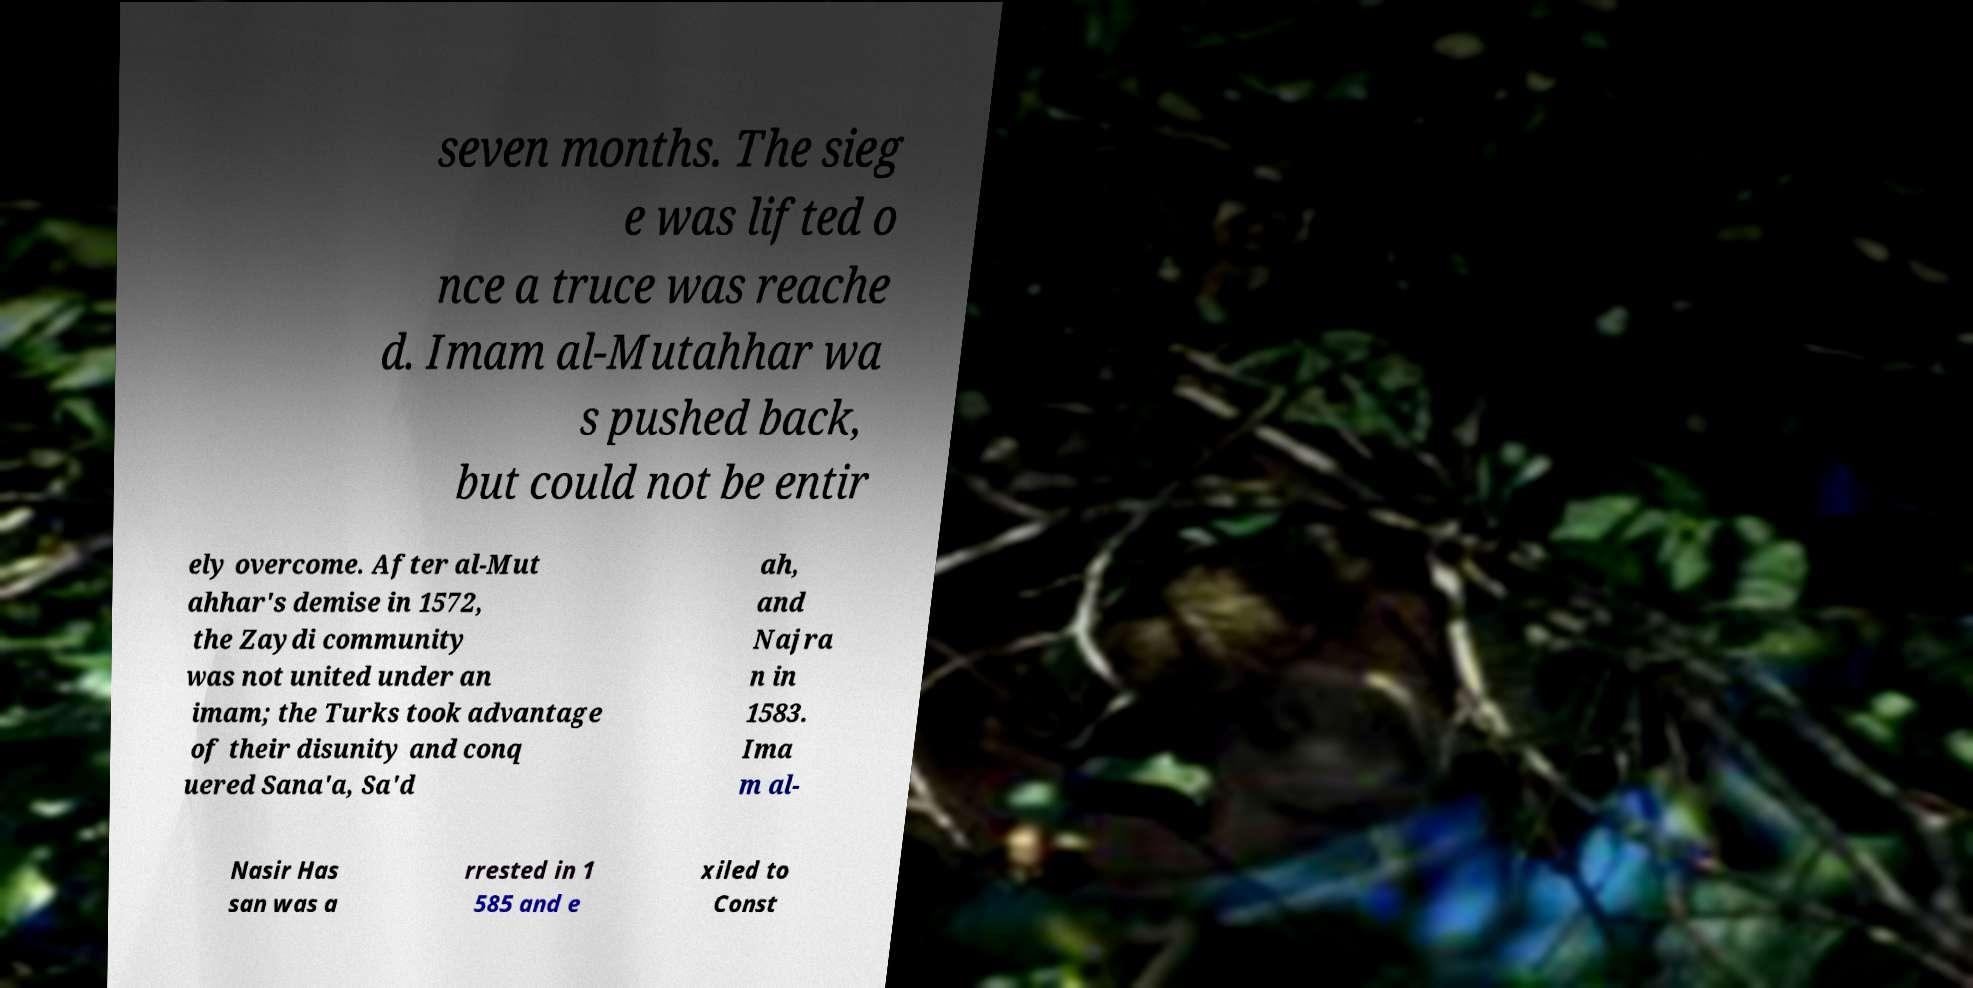Can you accurately transcribe the text from the provided image for me? seven months. The sieg e was lifted o nce a truce was reache d. Imam al-Mutahhar wa s pushed back, but could not be entir ely overcome. After al-Mut ahhar's demise in 1572, the Zaydi community was not united under an imam; the Turks took advantage of their disunity and conq uered Sana'a, Sa'd ah, and Najra n in 1583. Ima m al- Nasir Has san was a rrested in 1 585 and e xiled to Const 